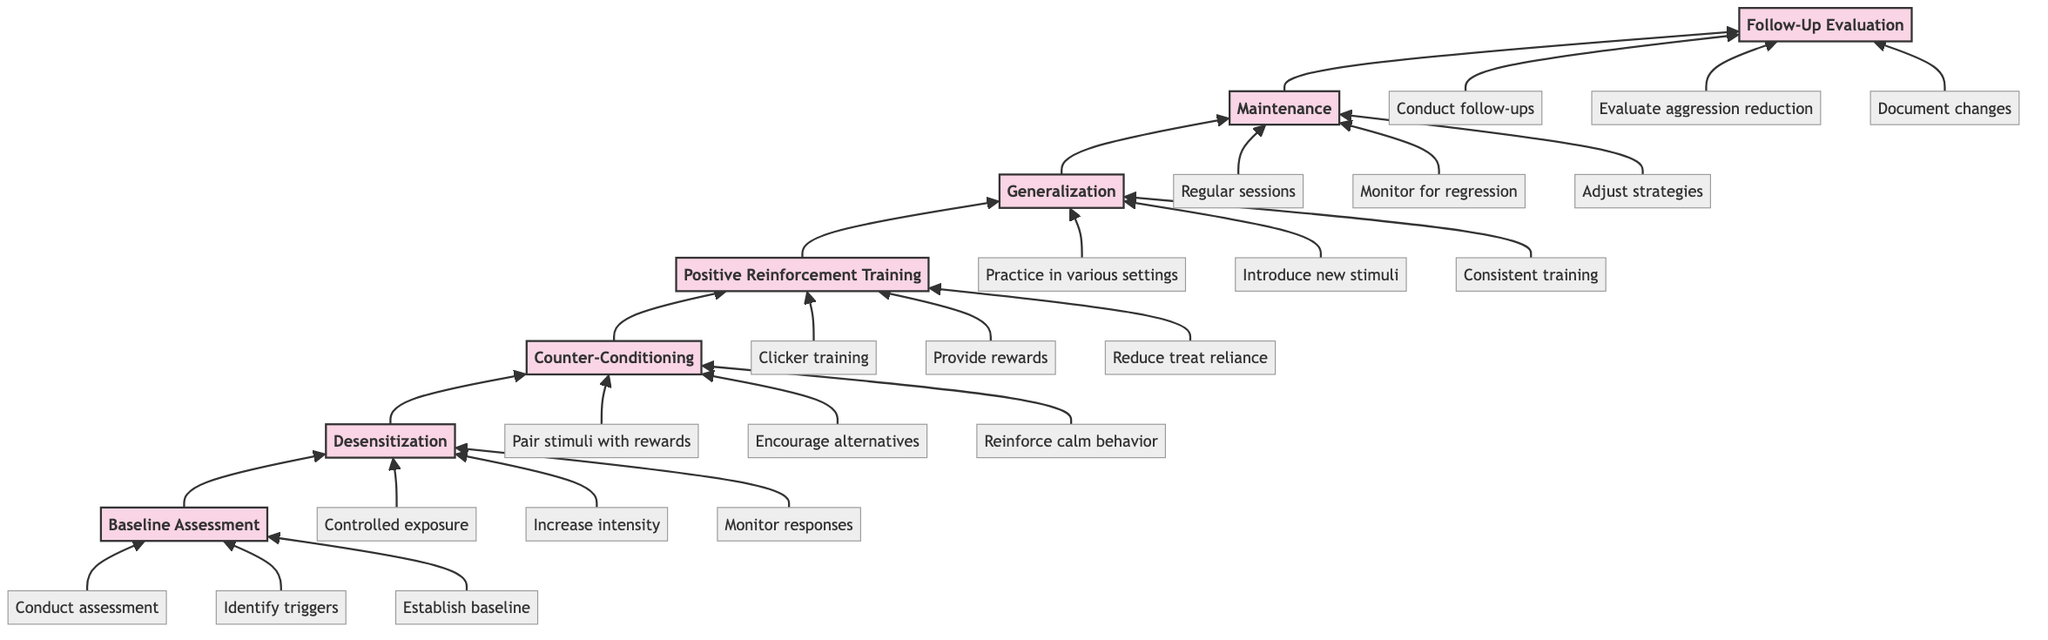What is the first stage of behavioral conditioning? The first stage in the diagram is the Baseline Assessment, which is connected directly to the second stage, Desensitization.
Answer: Baseline Assessment How many stages are there in total? The diagram contains a total of seven stages, as indicated by the nodes in the flowchart.
Answer: Seven What is the last task listed under Follow-Up Evaluation? The last task listed under Follow-Up Evaluation is Document changes, which is detailed at the endpoint of the flowchart.
Answer: Document changes What comes immediately after Positive Reinforcement Training? The stage that comes immediately after Positive Reinforcement Training in the flowchart is Generalization, as indicated by the arrow pointing up.
Answer: Generalization Which stage involves pairing fear stimuli with rewards? This task is included in the Counter-Conditioning stage, which aims to replace fear responses with positive behaviors.
Answer: Counter-Conditioning What is the primary goal of the Maintenance stage? The primary goal of the Maintenance stage is to sustain and monitor the conditioned behaviors, ensuring they remain effective over time.
Answer: Sustain and monitor Which task is performed at the Baseline Assessment stage? One of the tasks at the Baseline Assessment stage is to Identify triggers, which helps establish the specific fears involved.
Answer: Identify triggers How many tasks are listed under Generalization? There are three tasks listed under Generalization, detailing different approaches to ensure learned behaviors are demonstrated in various contexts.
Answer: Three 